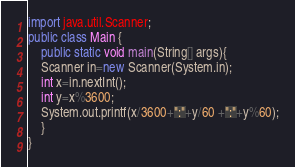<code> <loc_0><loc_0><loc_500><loc_500><_Java_>import java.util.Scanner;
public class Main {
    public static void main(String[] args){
    Scanner in=new Scanner(System.in);
    int x=in.nextInt();
    int y=x%3600;
    System.out.printf(x/3600+":"+y/60 +":"+y%60);
    }
}
</code> 